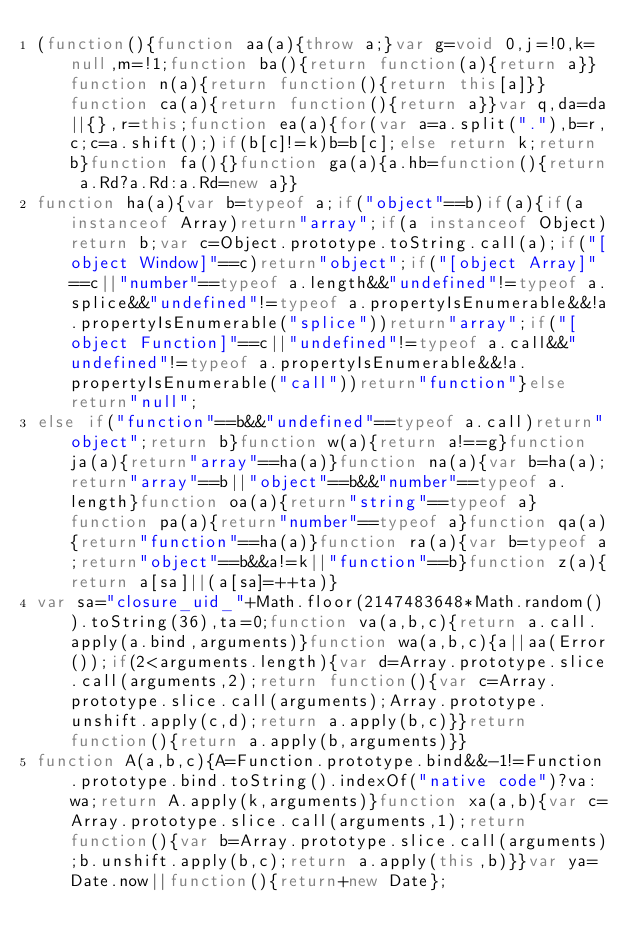<code> <loc_0><loc_0><loc_500><loc_500><_JavaScript_>(function(){function aa(a){throw a;}var g=void 0,j=!0,k=null,m=!1;function ba(){return function(a){return a}}function n(a){return function(){return this[a]}}function ca(a){return function(){return a}}var q,da=da||{},r=this;function ea(a){for(var a=a.split("."),b=r,c;c=a.shift();)if(b[c]!=k)b=b[c];else return k;return b}function fa(){}function ga(a){a.hb=function(){return a.Rd?a.Rd:a.Rd=new a}}
function ha(a){var b=typeof a;if("object"==b)if(a){if(a instanceof Array)return"array";if(a instanceof Object)return b;var c=Object.prototype.toString.call(a);if("[object Window]"==c)return"object";if("[object Array]"==c||"number"==typeof a.length&&"undefined"!=typeof a.splice&&"undefined"!=typeof a.propertyIsEnumerable&&!a.propertyIsEnumerable("splice"))return"array";if("[object Function]"==c||"undefined"!=typeof a.call&&"undefined"!=typeof a.propertyIsEnumerable&&!a.propertyIsEnumerable("call"))return"function"}else return"null";
else if("function"==b&&"undefined"==typeof a.call)return"object";return b}function w(a){return a!==g}function ja(a){return"array"==ha(a)}function na(a){var b=ha(a);return"array"==b||"object"==b&&"number"==typeof a.length}function oa(a){return"string"==typeof a}function pa(a){return"number"==typeof a}function qa(a){return"function"==ha(a)}function ra(a){var b=typeof a;return"object"==b&&a!=k||"function"==b}function z(a){return a[sa]||(a[sa]=++ta)}
var sa="closure_uid_"+Math.floor(2147483648*Math.random()).toString(36),ta=0;function va(a,b,c){return a.call.apply(a.bind,arguments)}function wa(a,b,c){a||aa(Error());if(2<arguments.length){var d=Array.prototype.slice.call(arguments,2);return function(){var c=Array.prototype.slice.call(arguments);Array.prototype.unshift.apply(c,d);return a.apply(b,c)}}return function(){return a.apply(b,arguments)}}
function A(a,b,c){A=Function.prototype.bind&&-1!=Function.prototype.bind.toString().indexOf("native code")?va:wa;return A.apply(k,arguments)}function xa(a,b){var c=Array.prototype.slice.call(arguments,1);return function(){var b=Array.prototype.slice.call(arguments);b.unshift.apply(b,c);return a.apply(this,b)}}var ya=Date.now||function(){return+new Date};</code> 